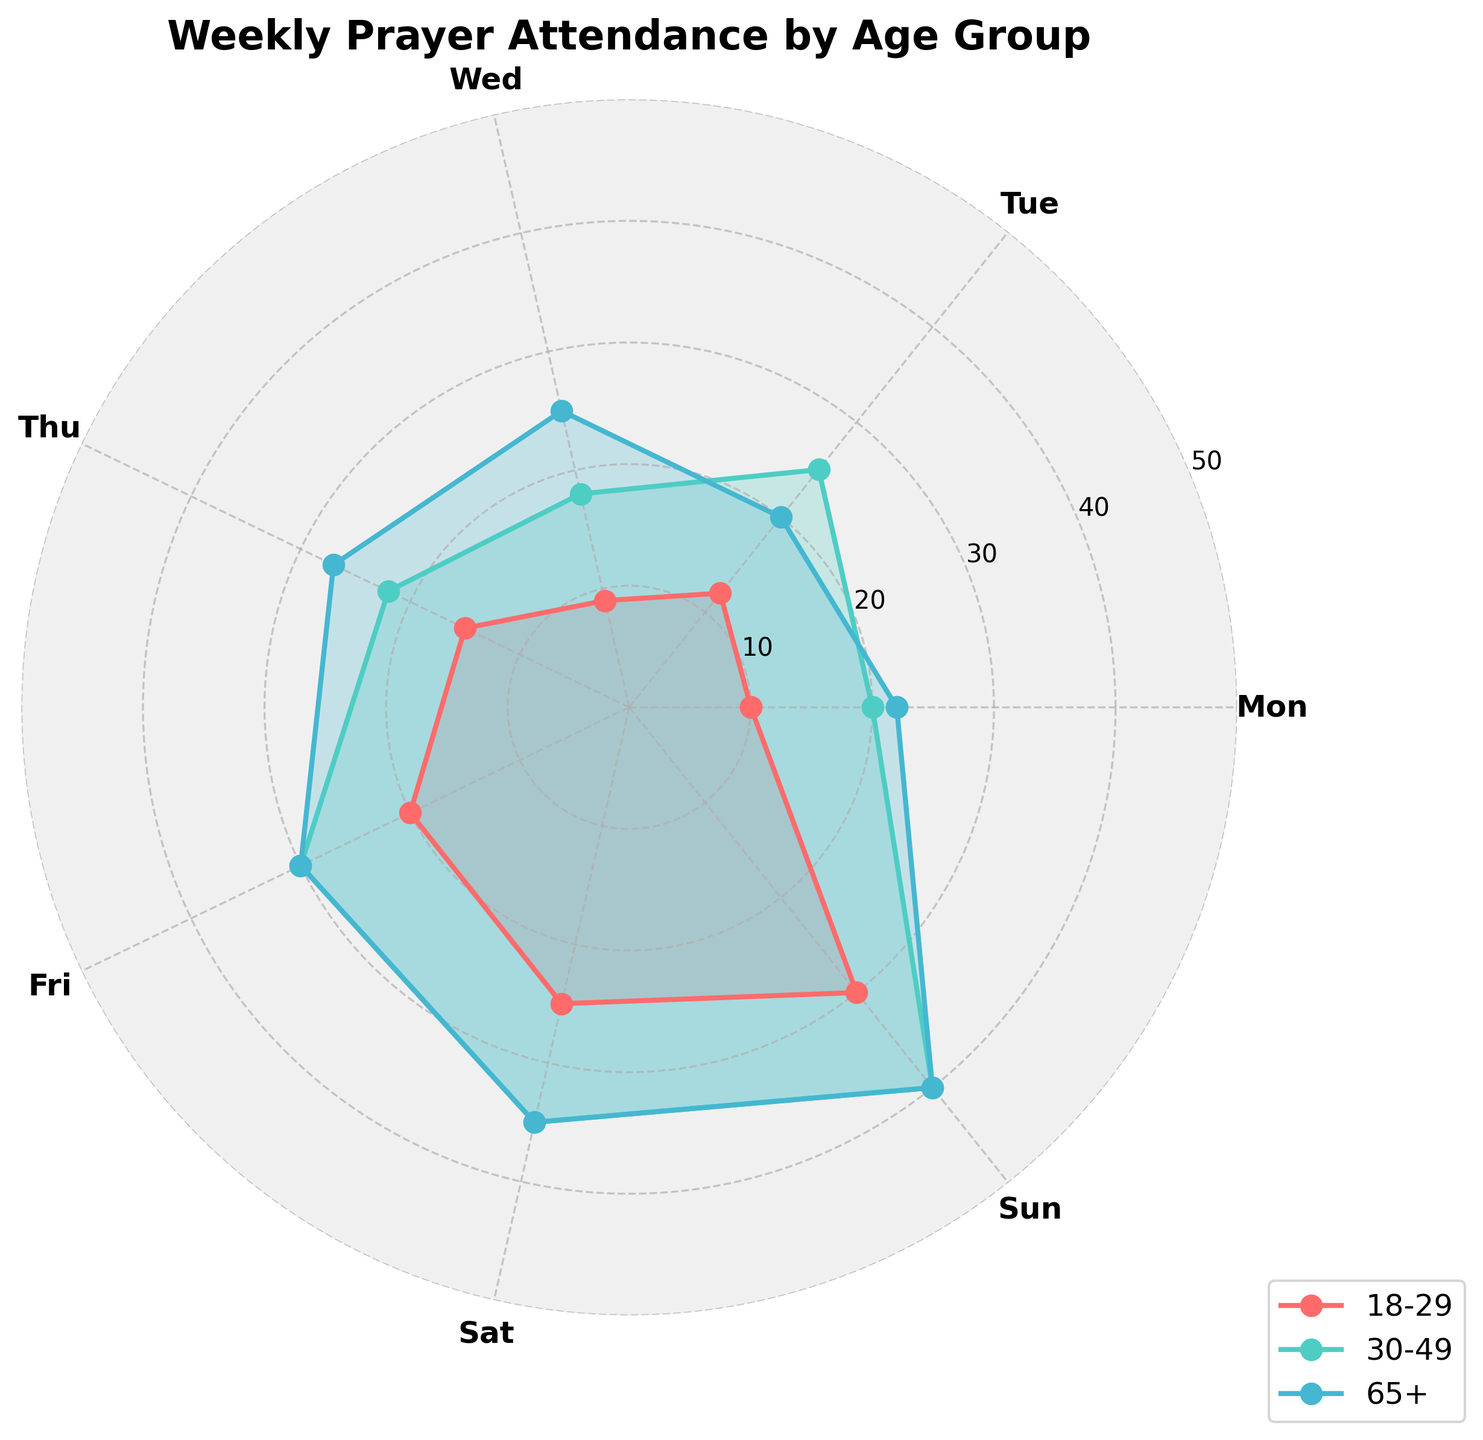What is the title of the radar chart? The title is placed at the top of the radar chart and is meant to provide a quick understanding of what the chart represents.
Answer: Weekly Prayer Attendance by Age Group Which day shows the highest prayer attendance for the 30-49 age group? The 30-49 age group can be identified by its respective color. Looking at the chart, the highest value for this group occurs on Sunday, where the prayer attendance reaches the peak.
Answer: Sunday What is the average prayer attendance on Saturday across all age groups shown? To find the average, look at the values for Saturday for each age group, add them together, and divide by the number of age groups (25 + 35 + 35) / 3. The sum is 95, and the average is 95 divided by 3.
Answer: 31.67 Which age group has the lowest prayer attendance on Wednesday? By observing the points for Wednesday for all age groups, the 18-29 age group has the lowest attendance with a value of 9.
Answer: 18-29 How does the prayer attendance on Friday for the 65+ age group compare to that of the 18-29 age group? By checking the attendance on Friday for both groups, the 65+ age group has a value of 30 while the 18-29 age group has a value of 20. Comparing these values shows that the 65+ age group has a higher attendance.
Answer: 65+ higher On which day is the prayer attendance the same for both the 30-49 and 65+ age groups? By comparing the values for each day, Thursday shows the same prayer attendance for both age groups, with each having a value of 27.
Answer: Thursday What is the total prayer attendance for the 18-29 age group for the entire week? Add the attendance values for each day for the 18-29 age group: (10 + 12 + 9 + 15 + 20 + 25 + 30). The sum is 121.
Answer: 121 Which age group's prayer attendance on Monday is closest to the prayer attendance on Monday for the 18-29 group? The 18-29 group has a value of 10 on Monday. Comparing other groups: 30-49 is closest with 20, 50-64 is closest with 15, 65+ is closest with 22. The 50-64 group, with 15, is closest to 10.
Answer: 50-64 